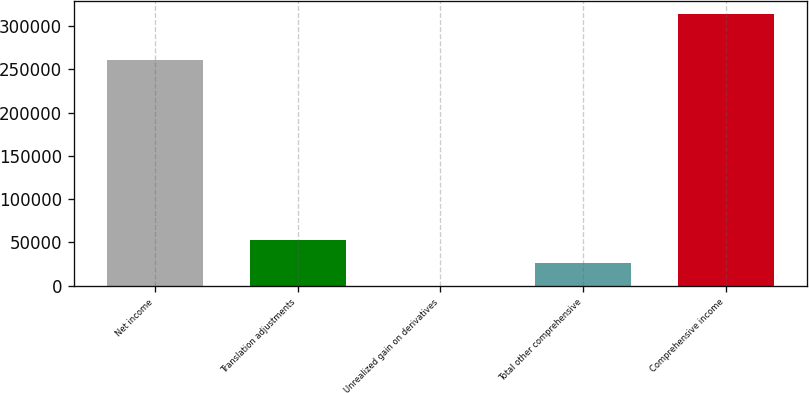Convert chart. <chart><loc_0><loc_0><loc_500><loc_500><bar_chart><fcel>Net income<fcel>Translation adjustments<fcel>Unrealized gain on derivatives<fcel>Total other comprehensive<fcel>Comprehensive income<nl><fcel>260716<fcel>52769.4<fcel>49<fcel>26409.2<fcel>313436<nl></chart> 